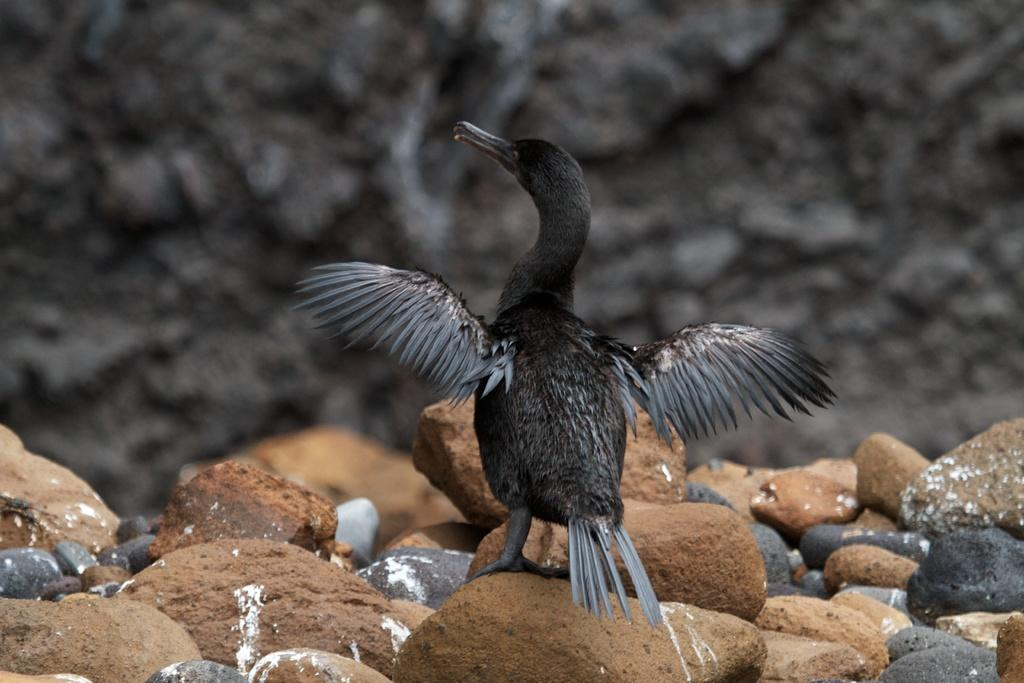What type of animal is in the image? There is a bird in the image. Can you describe the bird's appearance? The bird is black and gray in color. What else can be seen in the image besides the bird? There are many stones of different sizes and colors in the image. What is the overall tone of the image? The background of the image is dark. What type of crime is being committed in the image? There is no crime being committed in the image; it features a bird and stones. How many rings are visible in the image? There are no rings present in the image. 